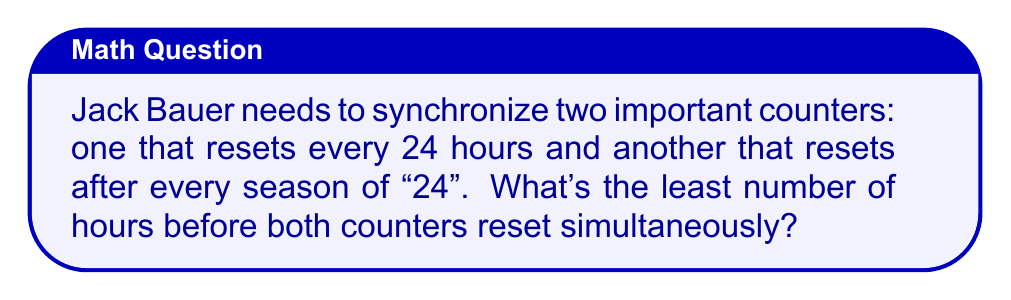Provide a solution to this math problem. To solve this problem, we need to find the least common multiple (LCM) of 24 and the number of episodes in a season of "24".

Step 1: Determine the number of episodes in a season of "24".
Each season of "24" typically has 24 episodes.

Step 2: Find the LCM of 24 and 24.
To find the LCM, we first need to find the prime factorization of both numbers:

$24 = 2^3 \times 3$

The LCM will be the product of the highest power of each prime factor:

$LCM(24, 24) = 2^3 \times 3 = 24$

Step 3: Convert the result to hours.
Since each unit in our LCM represents 1 hour, the result is already in hours.

Therefore, the least number of hours before both counters reset simultaneously is 24 hours.
Answer: 24 hours 